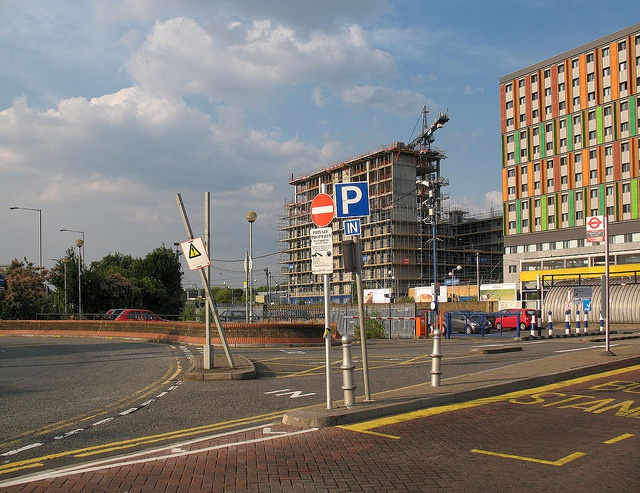Describe the objects in this image and their specific colors. I can see parking meter in darkgray, blue, ivory, navy, and darkblue tones, car in darkgray, black, maroon, gray, and brown tones, car in darkgray, gray, black, and blue tones, car in darkgray, brown, black, maroon, and salmon tones, and car in darkgray, gray, black, and purple tones in this image. 